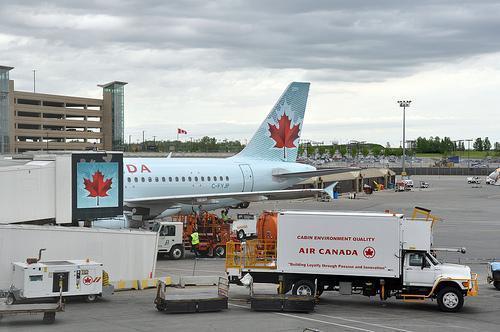How many planes are in the picture?
Give a very brief answer. 1. 